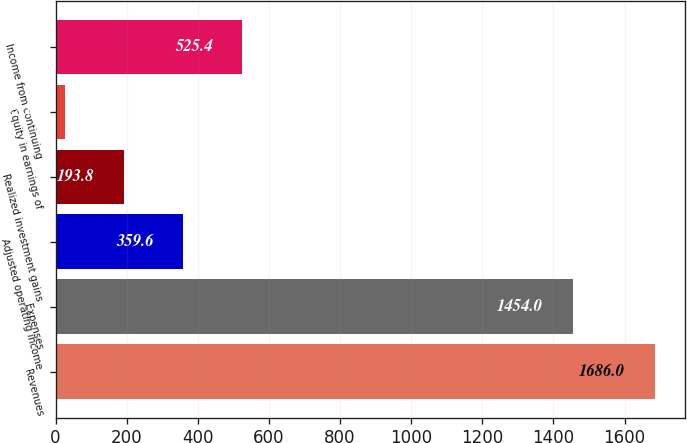Convert chart to OTSL. <chart><loc_0><loc_0><loc_500><loc_500><bar_chart><fcel>Revenues<fcel>Expenses<fcel>Adjusted operating income<fcel>Realized investment gains<fcel>Equity in earnings of<fcel>Income from continuing<nl><fcel>1686<fcel>1454<fcel>359.6<fcel>193.8<fcel>28<fcel>525.4<nl></chart> 